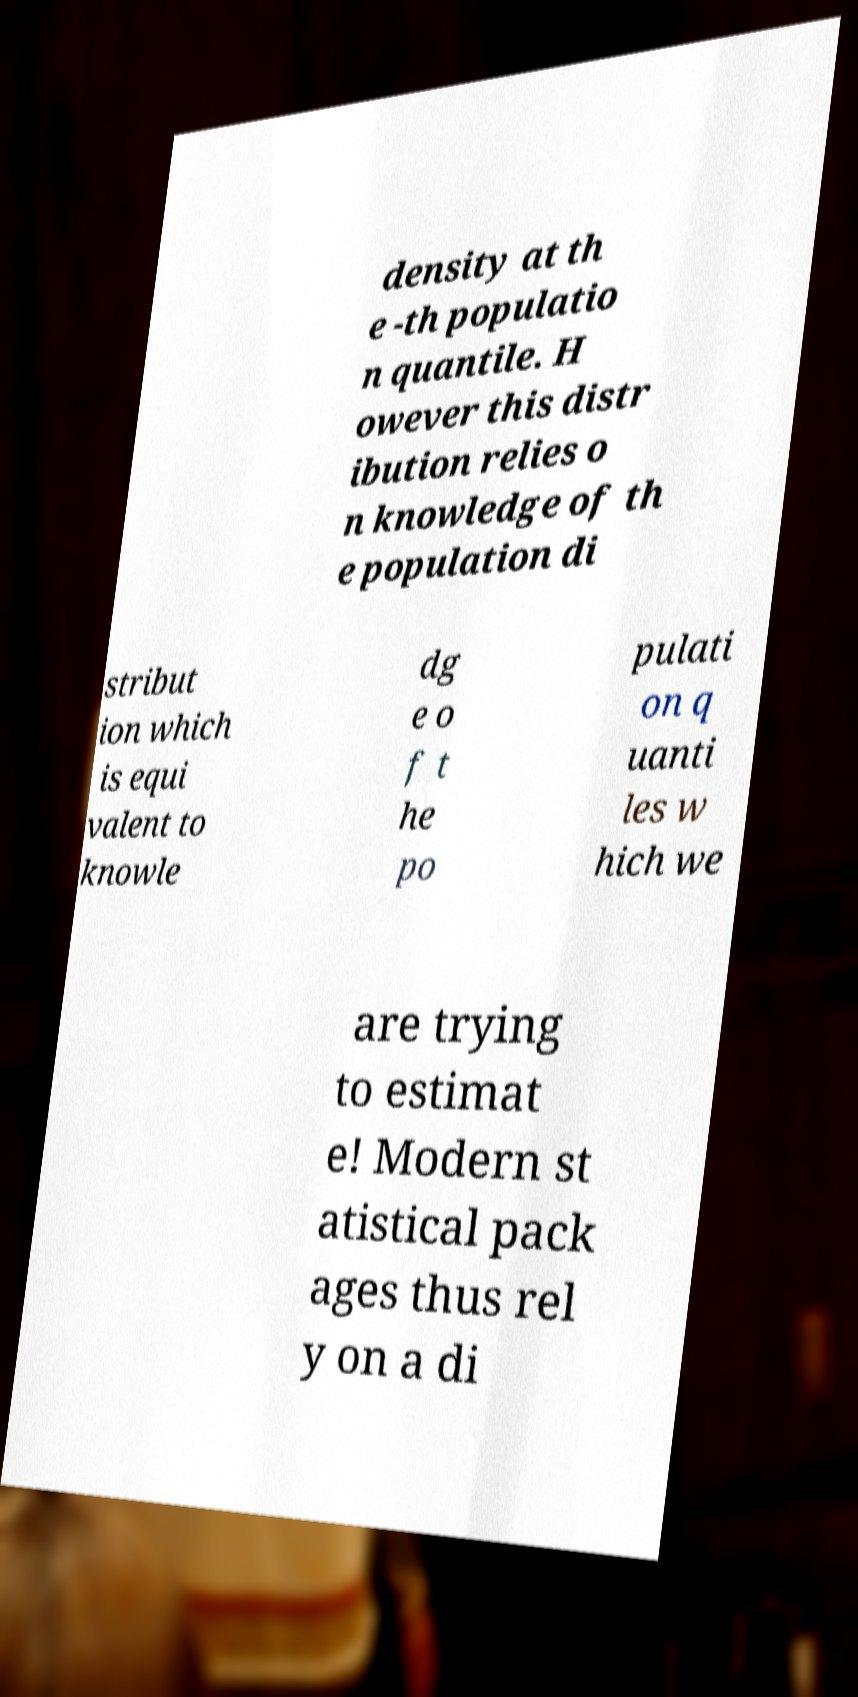There's text embedded in this image that I need extracted. Can you transcribe it verbatim? density at th e -th populatio n quantile. H owever this distr ibution relies o n knowledge of th e population di stribut ion which is equi valent to knowle dg e o f t he po pulati on q uanti les w hich we are trying to estimat e! Modern st atistical pack ages thus rel y on a di 